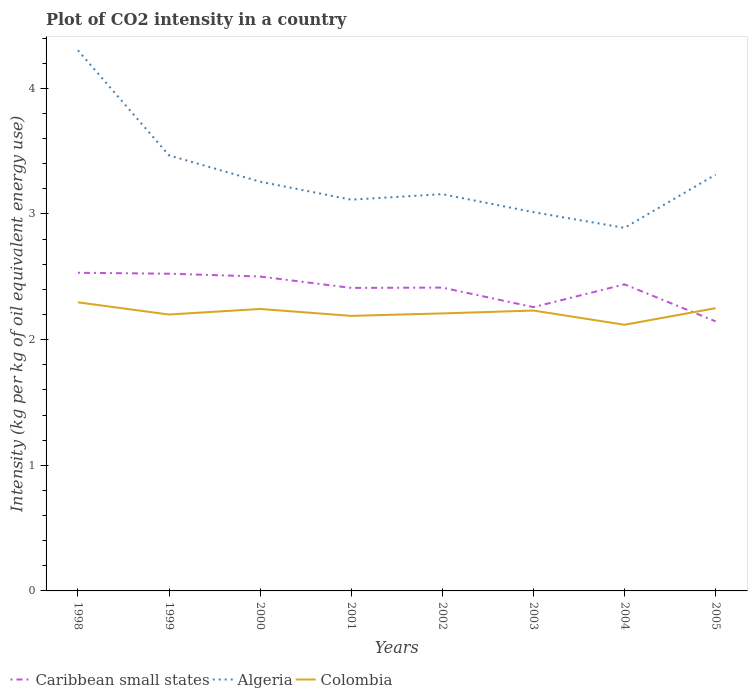Does the line corresponding to Algeria intersect with the line corresponding to Colombia?
Make the answer very short. No. Is the number of lines equal to the number of legend labels?
Provide a succinct answer. Yes. Across all years, what is the maximum CO2 intensity in in Caribbean small states?
Offer a terse response. 2.15. What is the total CO2 intensity in in Colombia in the graph?
Make the answer very short. -0.04. What is the difference between the highest and the second highest CO2 intensity in in Caribbean small states?
Your response must be concise. 0.39. What is the difference between the highest and the lowest CO2 intensity in in Algeria?
Your answer should be compact. 2. Is the CO2 intensity in in Caribbean small states strictly greater than the CO2 intensity in in Algeria over the years?
Your response must be concise. Yes. How many lines are there?
Your response must be concise. 3. Are the values on the major ticks of Y-axis written in scientific E-notation?
Keep it short and to the point. No. Does the graph contain any zero values?
Make the answer very short. No. Where does the legend appear in the graph?
Ensure brevity in your answer.  Bottom left. How are the legend labels stacked?
Ensure brevity in your answer.  Horizontal. What is the title of the graph?
Your answer should be very brief. Plot of CO2 intensity in a country. Does "High income" appear as one of the legend labels in the graph?
Offer a very short reply. No. What is the label or title of the X-axis?
Your answer should be very brief. Years. What is the label or title of the Y-axis?
Provide a succinct answer. Intensity (kg per kg of oil equivalent energy use). What is the Intensity (kg per kg of oil equivalent energy use) in Caribbean small states in 1998?
Provide a succinct answer. 2.53. What is the Intensity (kg per kg of oil equivalent energy use) in Algeria in 1998?
Make the answer very short. 4.3. What is the Intensity (kg per kg of oil equivalent energy use) in Colombia in 1998?
Your answer should be very brief. 2.3. What is the Intensity (kg per kg of oil equivalent energy use) in Caribbean small states in 1999?
Keep it short and to the point. 2.52. What is the Intensity (kg per kg of oil equivalent energy use) of Algeria in 1999?
Your response must be concise. 3.47. What is the Intensity (kg per kg of oil equivalent energy use) of Colombia in 1999?
Ensure brevity in your answer.  2.2. What is the Intensity (kg per kg of oil equivalent energy use) of Caribbean small states in 2000?
Ensure brevity in your answer.  2.5. What is the Intensity (kg per kg of oil equivalent energy use) of Algeria in 2000?
Your answer should be compact. 3.26. What is the Intensity (kg per kg of oil equivalent energy use) in Colombia in 2000?
Offer a terse response. 2.24. What is the Intensity (kg per kg of oil equivalent energy use) of Caribbean small states in 2001?
Your answer should be compact. 2.41. What is the Intensity (kg per kg of oil equivalent energy use) of Algeria in 2001?
Give a very brief answer. 3.11. What is the Intensity (kg per kg of oil equivalent energy use) of Colombia in 2001?
Provide a short and direct response. 2.19. What is the Intensity (kg per kg of oil equivalent energy use) in Caribbean small states in 2002?
Provide a succinct answer. 2.41. What is the Intensity (kg per kg of oil equivalent energy use) in Algeria in 2002?
Your answer should be compact. 3.16. What is the Intensity (kg per kg of oil equivalent energy use) in Colombia in 2002?
Keep it short and to the point. 2.21. What is the Intensity (kg per kg of oil equivalent energy use) of Caribbean small states in 2003?
Provide a short and direct response. 2.26. What is the Intensity (kg per kg of oil equivalent energy use) of Algeria in 2003?
Offer a very short reply. 3.01. What is the Intensity (kg per kg of oil equivalent energy use) of Colombia in 2003?
Make the answer very short. 2.23. What is the Intensity (kg per kg of oil equivalent energy use) in Caribbean small states in 2004?
Keep it short and to the point. 2.44. What is the Intensity (kg per kg of oil equivalent energy use) in Algeria in 2004?
Keep it short and to the point. 2.89. What is the Intensity (kg per kg of oil equivalent energy use) in Colombia in 2004?
Keep it short and to the point. 2.12. What is the Intensity (kg per kg of oil equivalent energy use) of Caribbean small states in 2005?
Offer a very short reply. 2.15. What is the Intensity (kg per kg of oil equivalent energy use) of Algeria in 2005?
Offer a terse response. 3.31. What is the Intensity (kg per kg of oil equivalent energy use) in Colombia in 2005?
Provide a succinct answer. 2.25. Across all years, what is the maximum Intensity (kg per kg of oil equivalent energy use) in Caribbean small states?
Provide a succinct answer. 2.53. Across all years, what is the maximum Intensity (kg per kg of oil equivalent energy use) in Algeria?
Your response must be concise. 4.3. Across all years, what is the maximum Intensity (kg per kg of oil equivalent energy use) in Colombia?
Your answer should be compact. 2.3. Across all years, what is the minimum Intensity (kg per kg of oil equivalent energy use) of Caribbean small states?
Your answer should be compact. 2.15. Across all years, what is the minimum Intensity (kg per kg of oil equivalent energy use) in Algeria?
Make the answer very short. 2.89. Across all years, what is the minimum Intensity (kg per kg of oil equivalent energy use) of Colombia?
Offer a very short reply. 2.12. What is the total Intensity (kg per kg of oil equivalent energy use) of Caribbean small states in the graph?
Make the answer very short. 19.23. What is the total Intensity (kg per kg of oil equivalent energy use) of Algeria in the graph?
Ensure brevity in your answer.  26.51. What is the total Intensity (kg per kg of oil equivalent energy use) of Colombia in the graph?
Your answer should be compact. 17.74. What is the difference between the Intensity (kg per kg of oil equivalent energy use) of Caribbean small states in 1998 and that in 1999?
Make the answer very short. 0.01. What is the difference between the Intensity (kg per kg of oil equivalent energy use) in Algeria in 1998 and that in 1999?
Your response must be concise. 0.84. What is the difference between the Intensity (kg per kg of oil equivalent energy use) of Colombia in 1998 and that in 1999?
Offer a terse response. 0.1. What is the difference between the Intensity (kg per kg of oil equivalent energy use) in Caribbean small states in 1998 and that in 2000?
Offer a very short reply. 0.03. What is the difference between the Intensity (kg per kg of oil equivalent energy use) in Algeria in 1998 and that in 2000?
Offer a very short reply. 1.05. What is the difference between the Intensity (kg per kg of oil equivalent energy use) in Colombia in 1998 and that in 2000?
Provide a short and direct response. 0.05. What is the difference between the Intensity (kg per kg of oil equivalent energy use) of Caribbean small states in 1998 and that in 2001?
Keep it short and to the point. 0.12. What is the difference between the Intensity (kg per kg of oil equivalent energy use) in Algeria in 1998 and that in 2001?
Give a very brief answer. 1.19. What is the difference between the Intensity (kg per kg of oil equivalent energy use) of Colombia in 1998 and that in 2001?
Provide a short and direct response. 0.11. What is the difference between the Intensity (kg per kg of oil equivalent energy use) in Caribbean small states in 1998 and that in 2002?
Your answer should be very brief. 0.12. What is the difference between the Intensity (kg per kg of oil equivalent energy use) of Algeria in 1998 and that in 2002?
Ensure brevity in your answer.  1.14. What is the difference between the Intensity (kg per kg of oil equivalent energy use) of Colombia in 1998 and that in 2002?
Keep it short and to the point. 0.09. What is the difference between the Intensity (kg per kg of oil equivalent energy use) in Caribbean small states in 1998 and that in 2003?
Make the answer very short. 0.27. What is the difference between the Intensity (kg per kg of oil equivalent energy use) of Algeria in 1998 and that in 2003?
Your response must be concise. 1.29. What is the difference between the Intensity (kg per kg of oil equivalent energy use) of Colombia in 1998 and that in 2003?
Offer a very short reply. 0.07. What is the difference between the Intensity (kg per kg of oil equivalent energy use) in Caribbean small states in 1998 and that in 2004?
Your response must be concise. 0.09. What is the difference between the Intensity (kg per kg of oil equivalent energy use) of Algeria in 1998 and that in 2004?
Make the answer very short. 1.41. What is the difference between the Intensity (kg per kg of oil equivalent energy use) of Colombia in 1998 and that in 2004?
Provide a short and direct response. 0.18. What is the difference between the Intensity (kg per kg of oil equivalent energy use) of Caribbean small states in 1998 and that in 2005?
Keep it short and to the point. 0.39. What is the difference between the Intensity (kg per kg of oil equivalent energy use) in Algeria in 1998 and that in 2005?
Ensure brevity in your answer.  0.99. What is the difference between the Intensity (kg per kg of oil equivalent energy use) of Colombia in 1998 and that in 2005?
Offer a terse response. 0.05. What is the difference between the Intensity (kg per kg of oil equivalent energy use) of Caribbean small states in 1999 and that in 2000?
Offer a very short reply. 0.02. What is the difference between the Intensity (kg per kg of oil equivalent energy use) in Algeria in 1999 and that in 2000?
Keep it short and to the point. 0.21. What is the difference between the Intensity (kg per kg of oil equivalent energy use) of Colombia in 1999 and that in 2000?
Provide a succinct answer. -0.04. What is the difference between the Intensity (kg per kg of oil equivalent energy use) in Caribbean small states in 1999 and that in 2001?
Offer a very short reply. 0.11. What is the difference between the Intensity (kg per kg of oil equivalent energy use) in Algeria in 1999 and that in 2001?
Ensure brevity in your answer.  0.35. What is the difference between the Intensity (kg per kg of oil equivalent energy use) of Colombia in 1999 and that in 2001?
Ensure brevity in your answer.  0.01. What is the difference between the Intensity (kg per kg of oil equivalent energy use) of Caribbean small states in 1999 and that in 2002?
Your response must be concise. 0.11. What is the difference between the Intensity (kg per kg of oil equivalent energy use) of Algeria in 1999 and that in 2002?
Ensure brevity in your answer.  0.31. What is the difference between the Intensity (kg per kg of oil equivalent energy use) in Colombia in 1999 and that in 2002?
Keep it short and to the point. -0.01. What is the difference between the Intensity (kg per kg of oil equivalent energy use) in Caribbean small states in 1999 and that in 2003?
Ensure brevity in your answer.  0.27. What is the difference between the Intensity (kg per kg of oil equivalent energy use) of Algeria in 1999 and that in 2003?
Make the answer very short. 0.45. What is the difference between the Intensity (kg per kg of oil equivalent energy use) of Colombia in 1999 and that in 2003?
Your answer should be very brief. -0.03. What is the difference between the Intensity (kg per kg of oil equivalent energy use) of Caribbean small states in 1999 and that in 2004?
Provide a short and direct response. 0.08. What is the difference between the Intensity (kg per kg of oil equivalent energy use) in Algeria in 1999 and that in 2004?
Your answer should be very brief. 0.58. What is the difference between the Intensity (kg per kg of oil equivalent energy use) in Colombia in 1999 and that in 2004?
Keep it short and to the point. 0.08. What is the difference between the Intensity (kg per kg of oil equivalent energy use) of Caribbean small states in 1999 and that in 2005?
Keep it short and to the point. 0.38. What is the difference between the Intensity (kg per kg of oil equivalent energy use) in Algeria in 1999 and that in 2005?
Your answer should be compact. 0.15. What is the difference between the Intensity (kg per kg of oil equivalent energy use) of Colombia in 1999 and that in 2005?
Make the answer very short. -0.05. What is the difference between the Intensity (kg per kg of oil equivalent energy use) of Caribbean small states in 2000 and that in 2001?
Provide a succinct answer. 0.09. What is the difference between the Intensity (kg per kg of oil equivalent energy use) of Algeria in 2000 and that in 2001?
Make the answer very short. 0.14. What is the difference between the Intensity (kg per kg of oil equivalent energy use) of Colombia in 2000 and that in 2001?
Offer a very short reply. 0.05. What is the difference between the Intensity (kg per kg of oil equivalent energy use) of Caribbean small states in 2000 and that in 2002?
Keep it short and to the point. 0.09. What is the difference between the Intensity (kg per kg of oil equivalent energy use) of Algeria in 2000 and that in 2002?
Your answer should be very brief. 0.1. What is the difference between the Intensity (kg per kg of oil equivalent energy use) of Colombia in 2000 and that in 2002?
Give a very brief answer. 0.04. What is the difference between the Intensity (kg per kg of oil equivalent energy use) in Caribbean small states in 2000 and that in 2003?
Keep it short and to the point. 0.24. What is the difference between the Intensity (kg per kg of oil equivalent energy use) in Algeria in 2000 and that in 2003?
Offer a terse response. 0.24. What is the difference between the Intensity (kg per kg of oil equivalent energy use) in Colombia in 2000 and that in 2003?
Provide a succinct answer. 0.01. What is the difference between the Intensity (kg per kg of oil equivalent energy use) in Caribbean small states in 2000 and that in 2004?
Offer a very short reply. 0.06. What is the difference between the Intensity (kg per kg of oil equivalent energy use) of Algeria in 2000 and that in 2004?
Your answer should be very brief. 0.37. What is the difference between the Intensity (kg per kg of oil equivalent energy use) in Colombia in 2000 and that in 2004?
Your answer should be very brief. 0.13. What is the difference between the Intensity (kg per kg of oil equivalent energy use) in Caribbean small states in 2000 and that in 2005?
Your answer should be compact. 0.36. What is the difference between the Intensity (kg per kg of oil equivalent energy use) of Algeria in 2000 and that in 2005?
Ensure brevity in your answer.  -0.06. What is the difference between the Intensity (kg per kg of oil equivalent energy use) of Colombia in 2000 and that in 2005?
Your answer should be compact. -0.01. What is the difference between the Intensity (kg per kg of oil equivalent energy use) in Caribbean small states in 2001 and that in 2002?
Provide a short and direct response. -0. What is the difference between the Intensity (kg per kg of oil equivalent energy use) of Algeria in 2001 and that in 2002?
Give a very brief answer. -0.04. What is the difference between the Intensity (kg per kg of oil equivalent energy use) in Colombia in 2001 and that in 2002?
Ensure brevity in your answer.  -0.02. What is the difference between the Intensity (kg per kg of oil equivalent energy use) of Caribbean small states in 2001 and that in 2003?
Make the answer very short. 0.15. What is the difference between the Intensity (kg per kg of oil equivalent energy use) in Algeria in 2001 and that in 2003?
Keep it short and to the point. 0.1. What is the difference between the Intensity (kg per kg of oil equivalent energy use) in Colombia in 2001 and that in 2003?
Provide a succinct answer. -0.04. What is the difference between the Intensity (kg per kg of oil equivalent energy use) of Caribbean small states in 2001 and that in 2004?
Ensure brevity in your answer.  -0.03. What is the difference between the Intensity (kg per kg of oil equivalent energy use) of Algeria in 2001 and that in 2004?
Offer a very short reply. 0.22. What is the difference between the Intensity (kg per kg of oil equivalent energy use) in Colombia in 2001 and that in 2004?
Make the answer very short. 0.07. What is the difference between the Intensity (kg per kg of oil equivalent energy use) in Caribbean small states in 2001 and that in 2005?
Your answer should be compact. 0.27. What is the difference between the Intensity (kg per kg of oil equivalent energy use) of Algeria in 2001 and that in 2005?
Offer a very short reply. -0.2. What is the difference between the Intensity (kg per kg of oil equivalent energy use) of Colombia in 2001 and that in 2005?
Your answer should be compact. -0.06. What is the difference between the Intensity (kg per kg of oil equivalent energy use) of Caribbean small states in 2002 and that in 2003?
Provide a succinct answer. 0.16. What is the difference between the Intensity (kg per kg of oil equivalent energy use) of Algeria in 2002 and that in 2003?
Offer a terse response. 0.14. What is the difference between the Intensity (kg per kg of oil equivalent energy use) in Colombia in 2002 and that in 2003?
Your answer should be compact. -0.02. What is the difference between the Intensity (kg per kg of oil equivalent energy use) of Caribbean small states in 2002 and that in 2004?
Provide a succinct answer. -0.03. What is the difference between the Intensity (kg per kg of oil equivalent energy use) of Algeria in 2002 and that in 2004?
Offer a very short reply. 0.27. What is the difference between the Intensity (kg per kg of oil equivalent energy use) of Colombia in 2002 and that in 2004?
Ensure brevity in your answer.  0.09. What is the difference between the Intensity (kg per kg of oil equivalent energy use) of Caribbean small states in 2002 and that in 2005?
Your answer should be compact. 0.27. What is the difference between the Intensity (kg per kg of oil equivalent energy use) in Algeria in 2002 and that in 2005?
Offer a terse response. -0.16. What is the difference between the Intensity (kg per kg of oil equivalent energy use) in Colombia in 2002 and that in 2005?
Ensure brevity in your answer.  -0.04. What is the difference between the Intensity (kg per kg of oil equivalent energy use) in Caribbean small states in 2003 and that in 2004?
Your response must be concise. -0.18. What is the difference between the Intensity (kg per kg of oil equivalent energy use) in Colombia in 2003 and that in 2004?
Provide a short and direct response. 0.11. What is the difference between the Intensity (kg per kg of oil equivalent energy use) of Caribbean small states in 2003 and that in 2005?
Your response must be concise. 0.11. What is the difference between the Intensity (kg per kg of oil equivalent energy use) in Algeria in 2003 and that in 2005?
Provide a succinct answer. -0.3. What is the difference between the Intensity (kg per kg of oil equivalent energy use) in Colombia in 2003 and that in 2005?
Ensure brevity in your answer.  -0.02. What is the difference between the Intensity (kg per kg of oil equivalent energy use) in Caribbean small states in 2004 and that in 2005?
Keep it short and to the point. 0.29. What is the difference between the Intensity (kg per kg of oil equivalent energy use) in Algeria in 2004 and that in 2005?
Give a very brief answer. -0.42. What is the difference between the Intensity (kg per kg of oil equivalent energy use) of Colombia in 2004 and that in 2005?
Ensure brevity in your answer.  -0.13. What is the difference between the Intensity (kg per kg of oil equivalent energy use) of Caribbean small states in 1998 and the Intensity (kg per kg of oil equivalent energy use) of Algeria in 1999?
Your answer should be compact. -0.93. What is the difference between the Intensity (kg per kg of oil equivalent energy use) of Caribbean small states in 1998 and the Intensity (kg per kg of oil equivalent energy use) of Colombia in 1999?
Provide a succinct answer. 0.33. What is the difference between the Intensity (kg per kg of oil equivalent energy use) in Algeria in 1998 and the Intensity (kg per kg of oil equivalent energy use) in Colombia in 1999?
Ensure brevity in your answer.  2.1. What is the difference between the Intensity (kg per kg of oil equivalent energy use) of Caribbean small states in 1998 and the Intensity (kg per kg of oil equivalent energy use) of Algeria in 2000?
Your answer should be compact. -0.72. What is the difference between the Intensity (kg per kg of oil equivalent energy use) of Caribbean small states in 1998 and the Intensity (kg per kg of oil equivalent energy use) of Colombia in 2000?
Your answer should be very brief. 0.29. What is the difference between the Intensity (kg per kg of oil equivalent energy use) in Algeria in 1998 and the Intensity (kg per kg of oil equivalent energy use) in Colombia in 2000?
Keep it short and to the point. 2.06. What is the difference between the Intensity (kg per kg of oil equivalent energy use) in Caribbean small states in 1998 and the Intensity (kg per kg of oil equivalent energy use) in Algeria in 2001?
Offer a terse response. -0.58. What is the difference between the Intensity (kg per kg of oil equivalent energy use) of Caribbean small states in 1998 and the Intensity (kg per kg of oil equivalent energy use) of Colombia in 2001?
Offer a very short reply. 0.34. What is the difference between the Intensity (kg per kg of oil equivalent energy use) in Algeria in 1998 and the Intensity (kg per kg of oil equivalent energy use) in Colombia in 2001?
Give a very brief answer. 2.11. What is the difference between the Intensity (kg per kg of oil equivalent energy use) of Caribbean small states in 1998 and the Intensity (kg per kg of oil equivalent energy use) of Algeria in 2002?
Make the answer very short. -0.63. What is the difference between the Intensity (kg per kg of oil equivalent energy use) of Caribbean small states in 1998 and the Intensity (kg per kg of oil equivalent energy use) of Colombia in 2002?
Offer a very short reply. 0.32. What is the difference between the Intensity (kg per kg of oil equivalent energy use) in Algeria in 1998 and the Intensity (kg per kg of oil equivalent energy use) in Colombia in 2002?
Your response must be concise. 2.09. What is the difference between the Intensity (kg per kg of oil equivalent energy use) of Caribbean small states in 1998 and the Intensity (kg per kg of oil equivalent energy use) of Algeria in 2003?
Your response must be concise. -0.48. What is the difference between the Intensity (kg per kg of oil equivalent energy use) in Caribbean small states in 1998 and the Intensity (kg per kg of oil equivalent energy use) in Colombia in 2003?
Your response must be concise. 0.3. What is the difference between the Intensity (kg per kg of oil equivalent energy use) of Algeria in 1998 and the Intensity (kg per kg of oil equivalent energy use) of Colombia in 2003?
Make the answer very short. 2.07. What is the difference between the Intensity (kg per kg of oil equivalent energy use) in Caribbean small states in 1998 and the Intensity (kg per kg of oil equivalent energy use) in Algeria in 2004?
Keep it short and to the point. -0.36. What is the difference between the Intensity (kg per kg of oil equivalent energy use) in Caribbean small states in 1998 and the Intensity (kg per kg of oil equivalent energy use) in Colombia in 2004?
Offer a terse response. 0.41. What is the difference between the Intensity (kg per kg of oil equivalent energy use) of Algeria in 1998 and the Intensity (kg per kg of oil equivalent energy use) of Colombia in 2004?
Your response must be concise. 2.18. What is the difference between the Intensity (kg per kg of oil equivalent energy use) in Caribbean small states in 1998 and the Intensity (kg per kg of oil equivalent energy use) in Algeria in 2005?
Provide a short and direct response. -0.78. What is the difference between the Intensity (kg per kg of oil equivalent energy use) in Caribbean small states in 1998 and the Intensity (kg per kg of oil equivalent energy use) in Colombia in 2005?
Offer a very short reply. 0.28. What is the difference between the Intensity (kg per kg of oil equivalent energy use) of Algeria in 1998 and the Intensity (kg per kg of oil equivalent energy use) of Colombia in 2005?
Offer a very short reply. 2.05. What is the difference between the Intensity (kg per kg of oil equivalent energy use) of Caribbean small states in 1999 and the Intensity (kg per kg of oil equivalent energy use) of Algeria in 2000?
Your response must be concise. -0.73. What is the difference between the Intensity (kg per kg of oil equivalent energy use) of Caribbean small states in 1999 and the Intensity (kg per kg of oil equivalent energy use) of Colombia in 2000?
Provide a short and direct response. 0.28. What is the difference between the Intensity (kg per kg of oil equivalent energy use) of Algeria in 1999 and the Intensity (kg per kg of oil equivalent energy use) of Colombia in 2000?
Give a very brief answer. 1.22. What is the difference between the Intensity (kg per kg of oil equivalent energy use) of Caribbean small states in 1999 and the Intensity (kg per kg of oil equivalent energy use) of Algeria in 2001?
Your response must be concise. -0.59. What is the difference between the Intensity (kg per kg of oil equivalent energy use) in Caribbean small states in 1999 and the Intensity (kg per kg of oil equivalent energy use) in Colombia in 2001?
Your answer should be very brief. 0.34. What is the difference between the Intensity (kg per kg of oil equivalent energy use) in Algeria in 1999 and the Intensity (kg per kg of oil equivalent energy use) in Colombia in 2001?
Offer a terse response. 1.28. What is the difference between the Intensity (kg per kg of oil equivalent energy use) of Caribbean small states in 1999 and the Intensity (kg per kg of oil equivalent energy use) of Algeria in 2002?
Ensure brevity in your answer.  -0.63. What is the difference between the Intensity (kg per kg of oil equivalent energy use) in Caribbean small states in 1999 and the Intensity (kg per kg of oil equivalent energy use) in Colombia in 2002?
Give a very brief answer. 0.32. What is the difference between the Intensity (kg per kg of oil equivalent energy use) of Algeria in 1999 and the Intensity (kg per kg of oil equivalent energy use) of Colombia in 2002?
Ensure brevity in your answer.  1.26. What is the difference between the Intensity (kg per kg of oil equivalent energy use) in Caribbean small states in 1999 and the Intensity (kg per kg of oil equivalent energy use) in Algeria in 2003?
Provide a succinct answer. -0.49. What is the difference between the Intensity (kg per kg of oil equivalent energy use) in Caribbean small states in 1999 and the Intensity (kg per kg of oil equivalent energy use) in Colombia in 2003?
Your response must be concise. 0.29. What is the difference between the Intensity (kg per kg of oil equivalent energy use) in Algeria in 1999 and the Intensity (kg per kg of oil equivalent energy use) in Colombia in 2003?
Your answer should be very brief. 1.23. What is the difference between the Intensity (kg per kg of oil equivalent energy use) of Caribbean small states in 1999 and the Intensity (kg per kg of oil equivalent energy use) of Algeria in 2004?
Offer a terse response. -0.36. What is the difference between the Intensity (kg per kg of oil equivalent energy use) of Caribbean small states in 1999 and the Intensity (kg per kg of oil equivalent energy use) of Colombia in 2004?
Provide a succinct answer. 0.41. What is the difference between the Intensity (kg per kg of oil equivalent energy use) in Algeria in 1999 and the Intensity (kg per kg of oil equivalent energy use) in Colombia in 2004?
Make the answer very short. 1.35. What is the difference between the Intensity (kg per kg of oil equivalent energy use) of Caribbean small states in 1999 and the Intensity (kg per kg of oil equivalent energy use) of Algeria in 2005?
Give a very brief answer. -0.79. What is the difference between the Intensity (kg per kg of oil equivalent energy use) in Caribbean small states in 1999 and the Intensity (kg per kg of oil equivalent energy use) in Colombia in 2005?
Your answer should be very brief. 0.27. What is the difference between the Intensity (kg per kg of oil equivalent energy use) in Algeria in 1999 and the Intensity (kg per kg of oil equivalent energy use) in Colombia in 2005?
Make the answer very short. 1.22. What is the difference between the Intensity (kg per kg of oil equivalent energy use) of Caribbean small states in 2000 and the Intensity (kg per kg of oil equivalent energy use) of Algeria in 2001?
Make the answer very short. -0.61. What is the difference between the Intensity (kg per kg of oil equivalent energy use) of Caribbean small states in 2000 and the Intensity (kg per kg of oil equivalent energy use) of Colombia in 2001?
Ensure brevity in your answer.  0.31. What is the difference between the Intensity (kg per kg of oil equivalent energy use) of Algeria in 2000 and the Intensity (kg per kg of oil equivalent energy use) of Colombia in 2001?
Give a very brief answer. 1.07. What is the difference between the Intensity (kg per kg of oil equivalent energy use) of Caribbean small states in 2000 and the Intensity (kg per kg of oil equivalent energy use) of Algeria in 2002?
Ensure brevity in your answer.  -0.66. What is the difference between the Intensity (kg per kg of oil equivalent energy use) of Caribbean small states in 2000 and the Intensity (kg per kg of oil equivalent energy use) of Colombia in 2002?
Your answer should be very brief. 0.29. What is the difference between the Intensity (kg per kg of oil equivalent energy use) in Algeria in 2000 and the Intensity (kg per kg of oil equivalent energy use) in Colombia in 2002?
Provide a succinct answer. 1.05. What is the difference between the Intensity (kg per kg of oil equivalent energy use) in Caribbean small states in 2000 and the Intensity (kg per kg of oil equivalent energy use) in Algeria in 2003?
Provide a succinct answer. -0.51. What is the difference between the Intensity (kg per kg of oil equivalent energy use) of Caribbean small states in 2000 and the Intensity (kg per kg of oil equivalent energy use) of Colombia in 2003?
Provide a succinct answer. 0.27. What is the difference between the Intensity (kg per kg of oil equivalent energy use) of Algeria in 2000 and the Intensity (kg per kg of oil equivalent energy use) of Colombia in 2003?
Your response must be concise. 1.03. What is the difference between the Intensity (kg per kg of oil equivalent energy use) in Caribbean small states in 2000 and the Intensity (kg per kg of oil equivalent energy use) in Algeria in 2004?
Make the answer very short. -0.39. What is the difference between the Intensity (kg per kg of oil equivalent energy use) of Caribbean small states in 2000 and the Intensity (kg per kg of oil equivalent energy use) of Colombia in 2004?
Provide a short and direct response. 0.38. What is the difference between the Intensity (kg per kg of oil equivalent energy use) of Algeria in 2000 and the Intensity (kg per kg of oil equivalent energy use) of Colombia in 2004?
Offer a very short reply. 1.14. What is the difference between the Intensity (kg per kg of oil equivalent energy use) of Caribbean small states in 2000 and the Intensity (kg per kg of oil equivalent energy use) of Algeria in 2005?
Your answer should be compact. -0.81. What is the difference between the Intensity (kg per kg of oil equivalent energy use) in Caribbean small states in 2000 and the Intensity (kg per kg of oil equivalent energy use) in Colombia in 2005?
Keep it short and to the point. 0.25. What is the difference between the Intensity (kg per kg of oil equivalent energy use) in Algeria in 2000 and the Intensity (kg per kg of oil equivalent energy use) in Colombia in 2005?
Make the answer very short. 1.01. What is the difference between the Intensity (kg per kg of oil equivalent energy use) of Caribbean small states in 2001 and the Intensity (kg per kg of oil equivalent energy use) of Algeria in 2002?
Provide a short and direct response. -0.75. What is the difference between the Intensity (kg per kg of oil equivalent energy use) in Caribbean small states in 2001 and the Intensity (kg per kg of oil equivalent energy use) in Colombia in 2002?
Make the answer very short. 0.2. What is the difference between the Intensity (kg per kg of oil equivalent energy use) in Algeria in 2001 and the Intensity (kg per kg of oil equivalent energy use) in Colombia in 2002?
Give a very brief answer. 0.91. What is the difference between the Intensity (kg per kg of oil equivalent energy use) in Caribbean small states in 2001 and the Intensity (kg per kg of oil equivalent energy use) in Algeria in 2003?
Make the answer very short. -0.6. What is the difference between the Intensity (kg per kg of oil equivalent energy use) of Caribbean small states in 2001 and the Intensity (kg per kg of oil equivalent energy use) of Colombia in 2003?
Keep it short and to the point. 0.18. What is the difference between the Intensity (kg per kg of oil equivalent energy use) in Algeria in 2001 and the Intensity (kg per kg of oil equivalent energy use) in Colombia in 2003?
Provide a succinct answer. 0.88. What is the difference between the Intensity (kg per kg of oil equivalent energy use) of Caribbean small states in 2001 and the Intensity (kg per kg of oil equivalent energy use) of Algeria in 2004?
Your answer should be very brief. -0.48. What is the difference between the Intensity (kg per kg of oil equivalent energy use) in Caribbean small states in 2001 and the Intensity (kg per kg of oil equivalent energy use) in Colombia in 2004?
Keep it short and to the point. 0.29. What is the difference between the Intensity (kg per kg of oil equivalent energy use) of Caribbean small states in 2001 and the Intensity (kg per kg of oil equivalent energy use) of Algeria in 2005?
Give a very brief answer. -0.9. What is the difference between the Intensity (kg per kg of oil equivalent energy use) of Caribbean small states in 2001 and the Intensity (kg per kg of oil equivalent energy use) of Colombia in 2005?
Keep it short and to the point. 0.16. What is the difference between the Intensity (kg per kg of oil equivalent energy use) of Algeria in 2001 and the Intensity (kg per kg of oil equivalent energy use) of Colombia in 2005?
Provide a short and direct response. 0.86. What is the difference between the Intensity (kg per kg of oil equivalent energy use) in Caribbean small states in 2002 and the Intensity (kg per kg of oil equivalent energy use) in Algeria in 2003?
Your answer should be compact. -0.6. What is the difference between the Intensity (kg per kg of oil equivalent energy use) in Caribbean small states in 2002 and the Intensity (kg per kg of oil equivalent energy use) in Colombia in 2003?
Offer a terse response. 0.18. What is the difference between the Intensity (kg per kg of oil equivalent energy use) of Algeria in 2002 and the Intensity (kg per kg of oil equivalent energy use) of Colombia in 2003?
Provide a short and direct response. 0.93. What is the difference between the Intensity (kg per kg of oil equivalent energy use) in Caribbean small states in 2002 and the Intensity (kg per kg of oil equivalent energy use) in Algeria in 2004?
Provide a succinct answer. -0.48. What is the difference between the Intensity (kg per kg of oil equivalent energy use) of Caribbean small states in 2002 and the Intensity (kg per kg of oil equivalent energy use) of Colombia in 2004?
Offer a terse response. 0.3. What is the difference between the Intensity (kg per kg of oil equivalent energy use) of Algeria in 2002 and the Intensity (kg per kg of oil equivalent energy use) of Colombia in 2004?
Keep it short and to the point. 1.04. What is the difference between the Intensity (kg per kg of oil equivalent energy use) of Caribbean small states in 2002 and the Intensity (kg per kg of oil equivalent energy use) of Algeria in 2005?
Your response must be concise. -0.9. What is the difference between the Intensity (kg per kg of oil equivalent energy use) of Caribbean small states in 2002 and the Intensity (kg per kg of oil equivalent energy use) of Colombia in 2005?
Make the answer very short. 0.16. What is the difference between the Intensity (kg per kg of oil equivalent energy use) in Algeria in 2002 and the Intensity (kg per kg of oil equivalent energy use) in Colombia in 2005?
Provide a short and direct response. 0.91. What is the difference between the Intensity (kg per kg of oil equivalent energy use) of Caribbean small states in 2003 and the Intensity (kg per kg of oil equivalent energy use) of Algeria in 2004?
Your answer should be very brief. -0.63. What is the difference between the Intensity (kg per kg of oil equivalent energy use) in Caribbean small states in 2003 and the Intensity (kg per kg of oil equivalent energy use) in Colombia in 2004?
Offer a terse response. 0.14. What is the difference between the Intensity (kg per kg of oil equivalent energy use) in Algeria in 2003 and the Intensity (kg per kg of oil equivalent energy use) in Colombia in 2004?
Offer a terse response. 0.9. What is the difference between the Intensity (kg per kg of oil equivalent energy use) in Caribbean small states in 2003 and the Intensity (kg per kg of oil equivalent energy use) in Algeria in 2005?
Make the answer very short. -1.05. What is the difference between the Intensity (kg per kg of oil equivalent energy use) of Caribbean small states in 2003 and the Intensity (kg per kg of oil equivalent energy use) of Colombia in 2005?
Your response must be concise. 0.01. What is the difference between the Intensity (kg per kg of oil equivalent energy use) in Algeria in 2003 and the Intensity (kg per kg of oil equivalent energy use) in Colombia in 2005?
Provide a succinct answer. 0.76. What is the difference between the Intensity (kg per kg of oil equivalent energy use) in Caribbean small states in 2004 and the Intensity (kg per kg of oil equivalent energy use) in Algeria in 2005?
Ensure brevity in your answer.  -0.87. What is the difference between the Intensity (kg per kg of oil equivalent energy use) of Caribbean small states in 2004 and the Intensity (kg per kg of oil equivalent energy use) of Colombia in 2005?
Make the answer very short. 0.19. What is the difference between the Intensity (kg per kg of oil equivalent energy use) in Algeria in 2004 and the Intensity (kg per kg of oil equivalent energy use) in Colombia in 2005?
Your answer should be compact. 0.64. What is the average Intensity (kg per kg of oil equivalent energy use) in Caribbean small states per year?
Provide a succinct answer. 2.4. What is the average Intensity (kg per kg of oil equivalent energy use) of Algeria per year?
Ensure brevity in your answer.  3.31. What is the average Intensity (kg per kg of oil equivalent energy use) in Colombia per year?
Your answer should be very brief. 2.22. In the year 1998, what is the difference between the Intensity (kg per kg of oil equivalent energy use) of Caribbean small states and Intensity (kg per kg of oil equivalent energy use) of Algeria?
Give a very brief answer. -1.77. In the year 1998, what is the difference between the Intensity (kg per kg of oil equivalent energy use) in Caribbean small states and Intensity (kg per kg of oil equivalent energy use) in Colombia?
Keep it short and to the point. 0.24. In the year 1998, what is the difference between the Intensity (kg per kg of oil equivalent energy use) of Algeria and Intensity (kg per kg of oil equivalent energy use) of Colombia?
Keep it short and to the point. 2.01. In the year 1999, what is the difference between the Intensity (kg per kg of oil equivalent energy use) of Caribbean small states and Intensity (kg per kg of oil equivalent energy use) of Algeria?
Offer a very short reply. -0.94. In the year 1999, what is the difference between the Intensity (kg per kg of oil equivalent energy use) of Caribbean small states and Intensity (kg per kg of oil equivalent energy use) of Colombia?
Give a very brief answer. 0.32. In the year 1999, what is the difference between the Intensity (kg per kg of oil equivalent energy use) of Algeria and Intensity (kg per kg of oil equivalent energy use) of Colombia?
Your response must be concise. 1.27. In the year 2000, what is the difference between the Intensity (kg per kg of oil equivalent energy use) in Caribbean small states and Intensity (kg per kg of oil equivalent energy use) in Algeria?
Give a very brief answer. -0.75. In the year 2000, what is the difference between the Intensity (kg per kg of oil equivalent energy use) in Caribbean small states and Intensity (kg per kg of oil equivalent energy use) in Colombia?
Keep it short and to the point. 0.26. In the year 2001, what is the difference between the Intensity (kg per kg of oil equivalent energy use) of Caribbean small states and Intensity (kg per kg of oil equivalent energy use) of Algeria?
Offer a terse response. -0.7. In the year 2001, what is the difference between the Intensity (kg per kg of oil equivalent energy use) of Caribbean small states and Intensity (kg per kg of oil equivalent energy use) of Colombia?
Give a very brief answer. 0.22. In the year 2001, what is the difference between the Intensity (kg per kg of oil equivalent energy use) in Algeria and Intensity (kg per kg of oil equivalent energy use) in Colombia?
Offer a terse response. 0.92. In the year 2002, what is the difference between the Intensity (kg per kg of oil equivalent energy use) of Caribbean small states and Intensity (kg per kg of oil equivalent energy use) of Algeria?
Offer a terse response. -0.74. In the year 2002, what is the difference between the Intensity (kg per kg of oil equivalent energy use) in Caribbean small states and Intensity (kg per kg of oil equivalent energy use) in Colombia?
Your answer should be very brief. 0.21. In the year 2002, what is the difference between the Intensity (kg per kg of oil equivalent energy use) in Algeria and Intensity (kg per kg of oil equivalent energy use) in Colombia?
Keep it short and to the point. 0.95. In the year 2003, what is the difference between the Intensity (kg per kg of oil equivalent energy use) in Caribbean small states and Intensity (kg per kg of oil equivalent energy use) in Algeria?
Offer a very short reply. -0.76. In the year 2003, what is the difference between the Intensity (kg per kg of oil equivalent energy use) in Caribbean small states and Intensity (kg per kg of oil equivalent energy use) in Colombia?
Your answer should be compact. 0.03. In the year 2003, what is the difference between the Intensity (kg per kg of oil equivalent energy use) of Algeria and Intensity (kg per kg of oil equivalent energy use) of Colombia?
Your answer should be very brief. 0.78. In the year 2004, what is the difference between the Intensity (kg per kg of oil equivalent energy use) in Caribbean small states and Intensity (kg per kg of oil equivalent energy use) in Algeria?
Give a very brief answer. -0.45. In the year 2004, what is the difference between the Intensity (kg per kg of oil equivalent energy use) of Caribbean small states and Intensity (kg per kg of oil equivalent energy use) of Colombia?
Offer a very short reply. 0.32. In the year 2004, what is the difference between the Intensity (kg per kg of oil equivalent energy use) in Algeria and Intensity (kg per kg of oil equivalent energy use) in Colombia?
Give a very brief answer. 0.77. In the year 2005, what is the difference between the Intensity (kg per kg of oil equivalent energy use) in Caribbean small states and Intensity (kg per kg of oil equivalent energy use) in Algeria?
Your response must be concise. -1.17. In the year 2005, what is the difference between the Intensity (kg per kg of oil equivalent energy use) in Caribbean small states and Intensity (kg per kg of oil equivalent energy use) in Colombia?
Keep it short and to the point. -0.1. In the year 2005, what is the difference between the Intensity (kg per kg of oil equivalent energy use) in Algeria and Intensity (kg per kg of oil equivalent energy use) in Colombia?
Provide a short and direct response. 1.06. What is the ratio of the Intensity (kg per kg of oil equivalent energy use) in Algeria in 1998 to that in 1999?
Give a very brief answer. 1.24. What is the ratio of the Intensity (kg per kg of oil equivalent energy use) of Colombia in 1998 to that in 1999?
Provide a succinct answer. 1.04. What is the ratio of the Intensity (kg per kg of oil equivalent energy use) of Caribbean small states in 1998 to that in 2000?
Your answer should be compact. 1.01. What is the ratio of the Intensity (kg per kg of oil equivalent energy use) in Algeria in 1998 to that in 2000?
Give a very brief answer. 1.32. What is the ratio of the Intensity (kg per kg of oil equivalent energy use) in Colombia in 1998 to that in 2000?
Your response must be concise. 1.02. What is the ratio of the Intensity (kg per kg of oil equivalent energy use) in Caribbean small states in 1998 to that in 2001?
Your answer should be compact. 1.05. What is the ratio of the Intensity (kg per kg of oil equivalent energy use) of Algeria in 1998 to that in 2001?
Your answer should be very brief. 1.38. What is the ratio of the Intensity (kg per kg of oil equivalent energy use) in Colombia in 1998 to that in 2001?
Ensure brevity in your answer.  1.05. What is the ratio of the Intensity (kg per kg of oil equivalent energy use) in Caribbean small states in 1998 to that in 2002?
Your response must be concise. 1.05. What is the ratio of the Intensity (kg per kg of oil equivalent energy use) of Algeria in 1998 to that in 2002?
Ensure brevity in your answer.  1.36. What is the ratio of the Intensity (kg per kg of oil equivalent energy use) of Colombia in 1998 to that in 2002?
Ensure brevity in your answer.  1.04. What is the ratio of the Intensity (kg per kg of oil equivalent energy use) in Caribbean small states in 1998 to that in 2003?
Give a very brief answer. 1.12. What is the ratio of the Intensity (kg per kg of oil equivalent energy use) of Algeria in 1998 to that in 2003?
Ensure brevity in your answer.  1.43. What is the ratio of the Intensity (kg per kg of oil equivalent energy use) of Colombia in 1998 to that in 2003?
Your answer should be very brief. 1.03. What is the ratio of the Intensity (kg per kg of oil equivalent energy use) in Caribbean small states in 1998 to that in 2004?
Give a very brief answer. 1.04. What is the ratio of the Intensity (kg per kg of oil equivalent energy use) in Algeria in 1998 to that in 2004?
Give a very brief answer. 1.49. What is the ratio of the Intensity (kg per kg of oil equivalent energy use) of Colombia in 1998 to that in 2004?
Give a very brief answer. 1.08. What is the ratio of the Intensity (kg per kg of oil equivalent energy use) of Caribbean small states in 1998 to that in 2005?
Provide a succinct answer. 1.18. What is the ratio of the Intensity (kg per kg of oil equivalent energy use) of Algeria in 1998 to that in 2005?
Your answer should be very brief. 1.3. What is the ratio of the Intensity (kg per kg of oil equivalent energy use) of Colombia in 1998 to that in 2005?
Offer a very short reply. 1.02. What is the ratio of the Intensity (kg per kg of oil equivalent energy use) of Caribbean small states in 1999 to that in 2000?
Offer a terse response. 1.01. What is the ratio of the Intensity (kg per kg of oil equivalent energy use) of Algeria in 1999 to that in 2000?
Provide a short and direct response. 1.06. What is the ratio of the Intensity (kg per kg of oil equivalent energy use) in Colombia in 1999 to that in 2000?
Provide a short and direct response. 0.98. What is the ratio of the Intensity (kg per kg of oil equivalent energy use) in Caribbean small states in 1999 to that in 2001?
Your response must be concise. 1.05. What is the ratio of the Intensity (kg per kg of oil equivalent energy use) in Algeria in 1999 to that in 2001?
Offer a very short reply. 1.11. What is the ratio of the Intensity (kg per kg of oil equivalent energy use) in Caribbean small states in 1999 to that in 2002?
Give a very brief answer. 1.05. What is the ratio of the Intensity (kg per kg of oil equivalent energy use) of Algeria in 1999 to that in 2002?
Offer a very short reply. 1.1. What is the ratio of the Intensity (kg per kg of oil equivalent energy use) of Caribbean small states in 1999 to that in 2003?
Your response must be concise. 1.12. What is the ratio of the Intensity (kg per kg of oil equivalent energy use) of Algeria in 1999 to that in 2003?
Ensure brevity in your answer.  1.15. What is the ratio of the Intensity (kg per kg of oil equivalent energy use) of Colombia in 1999 to that in 2003?
Your response must be concise. 0.99. What is the ratio of the Intensity (kg per kg of oil equivalent energy use) of Caribbean small states in 1999 to that in 2004?
Ensure brevity in your answer.  1.03. What is the ratio of the Intensity (kg per kg of oil equivalent energy use) in Algeria in 1999 to that in 2004?
Keep it short and to the point. 1.2. What is the ratio of the Intensity (kg per kg of oil equivalent energy use) in Colombia in 1999 to that in 2004?
Keep it short and to the point. 1.04. What is the ratio of the Intensity (kg per kg of oil equivalent energy use) in Caribbean small states in 1999 to that in 2005?
Ensure brevity in your answer.  1.18. What is the ratio of the Intensity (kg per kg of oil equivalent energy use) in Algeria in 1999 to that in 2005?
Provide a short and direct response. 1.05. What is the ratio of the Intensity (kg per kg of oil equivalent energy use) in Colombia in 1999 to that in 2005?
Keep it short and to the point. 0.98. What is the ratio of the Intensity (kg per kg of oil equivalent energy use) of Caribbean small states in 2000 to that in 2001?
Offer a terse response. 1.04. What is the ratio of the Intensity (kg per kg of oil equivalent energy use) of Algeria in 2000 to that in 2001?
Your answer should be very brief. 1.05. What is the ratio of the Intensity (kg per kg of oil equivalent energy use) in Colombia in 2000 to that in 2001?
Keep it short and to the point. 1.03. What is the ratio of the Intensity (kg per kg of oil equivalent energy use) of Caribbean small states in 2000 to that in 2002?
Give a very brief answer. 1.04. What is the ratio of the Intensity (kg per kg of oil equivalent energy use) of Algeria in 2000 to that in 2002?
Offer a very short reply. 1.03. What is the ratio of the Intensity (kg per kg of oil equivalent energy use) in Colombia in 2000 to that in 2002?
Give a very brief answer. 1.02. What is the ratio of the Intensity (kg per kg of oil equivalent energy use) in Caribbean small states in 2000 to that in 2003?
Offer a very short reply. 1.11. What is the ratio of the Intensity (kg per kg of oil equivalent energy use) in Algeria in 2000 to that in 2003?
Offer a very short reply. 1.08. What is the ratio of the Intensity (kg per kg of oil equivalent energy use) in Colombia in 2000 to that in 2003?
Your response must be concise. 1.01. What is the ratio of the Intensity (kg per kg of oil equivalent energy use) in Caribbean small states in 2000 to that in 2004?
Provide a short and direct response. 1.03. What is the ratio of the Intensity (kg per kg of oil equivalent energy use) of Algeria in 2000 to that in 2004?
Make the answer very short. 1.13. What is the ratio of the Intensity (kg per kg of oil equivalent energy use) in Colombia in 2000 to that in 2004?
Your answer should be very brief. 1.06. What is the ratio of the Intensity (kg per kg of oil equivalent energy use) of Caribbean small states in 2000 to that in 2005?
Keep it short and to the point. 1.17. What is the ratio of the Intensity (kg per kg of oil equivalent energy use) of Algeria in 2000 to that in 2005?
Provide a short and direct response. 0.98. What is the ratio of the Intensity (kg per kg of oil equivalent energy use) of Algeria in 2001 to that in 2002?
Offer a very short reply. 0.99. What is the ratio of the Intensity (kg per kg of oil equivalent energy use) of Caribbean small states in 2001 to that in 2003?
Give a very brief answer. 1.07. What is the ratio of the Intensity (kg per kg of oil equivalent energy use) of Algeria in 2001 to that in 2003?
Offer a terse response. 1.03. What is the ratio of the Intensity (kg per kg of oil equivalent energy use) in Colombia in 2001 to that in 2003?
Keep it short and to the point. 0.98. What is the ratio of the Intensity (kg per kg of oil equivalent energy use) of Caribbean small states in 2001 to that in 2004?
Your response must be concise. 0.99. What is the ratio of the Intensity (kg per kg of oil equivalent energy use) of Algeria in 2001 to that in 2004?
Make the answer very short. 1.08. What is the ratio of the Intensity (kg per kg of oil equivalent energy use) of Colombia in 2001 to that in 2004?
Your answer should be very brief. 1.03. What is the ratio of the Intensity (kg per kg of oil equivalent energy use) of Caribbean small states in 2001 to that in 2005?
Provide a succinct answer. 1.12. What is the ratio of the Intensity (kg per kg of oil equivalent energy use) of Algeria in 2001 to that in 2005?
Your answer should be compact. 0.94. What is the ratio of the Intensity (kg per kg of oil equivalent energy use) in Colombia in 2001 to that in 2005?
Make the answer very short. 0.97. What is the ratio of the Intensity (kg per kg of oil equivalent energy use) of Caribbean small states in 2002 to that in 2003?
Your response must be concise. 1.07. What is the ratio of the Intensity (kg per kg of oil equivalent energy use) in Algeria in 2002 to that in 2003?
Keep it short and to the point. 1.05. What is the ratio of the Intensity (kg per kg of oil equivalent energy use) of Caribbean small states in 2002 to that in 2004?
Offer a terse response. 0.99. What is the ratio of the Intensity (kg per kg of oil equivalent energy use) in Algeria in 2002 to that in 2004?
Keep it short and to the point. 1.09. What is the ratio of the Intensity (kg per kg of oil equivalent energy use) of Colombia in 2002 to that in 2004?
Give a very brief answer. 1.04. What is the ratio of the Intensity (kg per kg of oil equivalent energy use) of Caribbean small states in 2002 to that in 2005?
Keep it short and to the point. 1.13. What is the ratio of the Intensity (kg per kg of oil equivalent energy use) of Algeria in 2002 to that in 2005?
Provide a succinct answer. 0.95. What is the ratio of the Intensity (kg per kg of oil equivalent energy use) in Colombia in 2002 to that in 2005?
Keep it short and to the point. 0.98. What is the ratio of the Intensity (kg per kg of oil equivalent energy use) in Caribbean small states in 2003 to that in 2004?
Offer a terse response. 0.93. What is the ratio of the Intensity (kg per kg of oil equivalent energy use) in Algeria in 2003 to that in 2004?
Make the answer very short. 1.04. What is the ratio of the Intensity (kg per kg of oil equivalent energy use) in Colombia in 2003 to that in 2004?
Provide a succinct answer. 1.05. What is the ratio of the Intensity (kg per kg of oil equivalent energy use) in Caribbean small states in 2003 to that in 2005?
Offer a very short reply. 1.05. What is the ratio of the Intensity (kg per kg of oil equivalent energy use) of Algeria in 2003 to that in 2005?
Ensure brevity in your answer.  0.91. What is the ratio of the Intensity (kg per kg of oil equivalent energy use) in Colombia in 2003 to that in 2005?
Your answer should be compact. 0.99. What is the ratio of the Intensity (kg per kg of oil equivalent energy use) of Caribbean small states in 2004 to that in 2005?
Your answer should be very brief. 1.14. What is the ratio of the Intensity (kg per kg of oil equivalent energy use) in Algeria in 2004 to that in 2005?
Keep it short and to the point. 0.87. What is the ratio of the Intensity (kg per kg of oil equivalent energy use) of Colombia in 2004 to that in 2005?
Make the answer very short. 0.94. What is the difference between the highest and the second highest Intensity (kg per kg of oil equivalent energy use) of Caribbean small states?
Provide a succinct answer. 0.01. What is the difference between the highest and the second highest Intensity (kg per kg of oil equivalent energy use) of Algeria?
Provide a succinct answer. 0.84. What is the difference between the highest and the second highest Intensity (kg per kg of oil equivalent energy use) of Colombia?
Offer a very short reply. 0.05. What is the difference between the highest and the lowest Intensity (kg per kg of oil equivalent energy use) of Caribbean small states?
Offer a very short reply. 0.39. What is the difference between the highest and the lowest Intensity (kg per kg of oil equivalent energy use) of Algeria?
Offer a terse response. 1.41. What is the difference between the highest and the lowest Intensity (kg per kg of oil equivalent energy use) of Colombia?
Your answer should be compact. 0.18. 